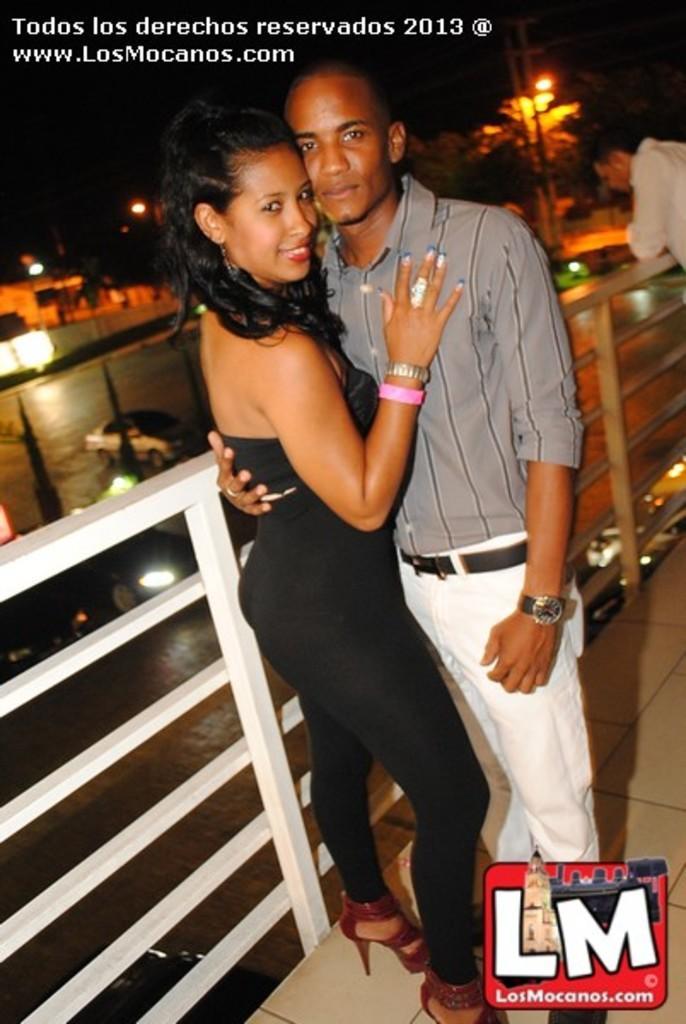How would you summarize this image in a sentence or two? In this image we can see some persons standing on the floor. One person is wearing a wristwatch on his hand. In the center of the image we can see a barricade. In the background, we can see group of vehicles parked on the ground, a group of trees , light poles. In the bottom of the image we can see a logo. In the top left side of the image we can see some text. 